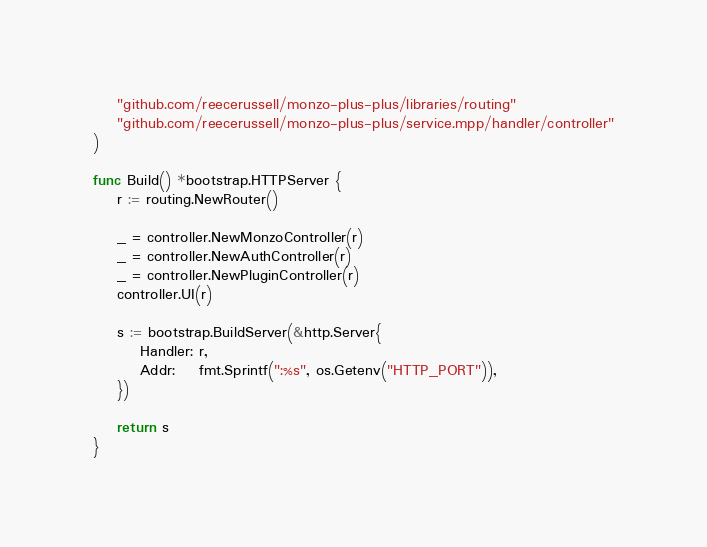<code> <loc_0><loc_0><loc_500><loc_500><_Go_>	"github.com/reecerussell/monzo-plus-plus/libraries/routing"
	"github.com/reecerussell/monzo-plus-plus/service.mpp/handler/controller"
)

func Build() *bootstrap.HTTPServer {
	r := routing.NewRouter()

	_ = controller.NewMonzoController(r)
	_ = controller.NewAuthController(r)
	_ = controller.NewPluginController(r)
	controller.UI(r)

	s := bootstrap.BuildServer(&http.Server{
		Handler: r,
		Addr:    fmt.Sprintf(":%s", os.Getenv("HTTP_PORT")),
	})

	return s
}
</code> 